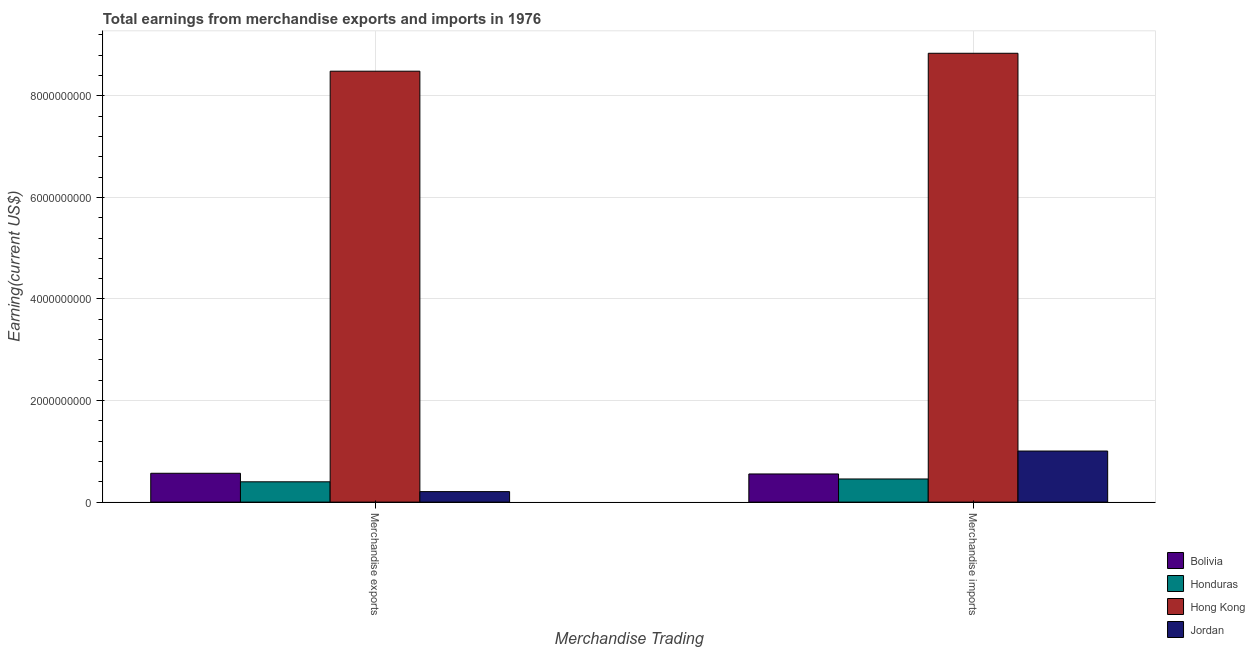How many different coloured bars are there?
Your response must be concise. 4. How many groups of bars are there?
Make the answer very short. 2. Are the number of bars per tick equal to the number of legend labels?
Offer a very short reply. Yes. Are the number of bars on each tick of the X-axis equal?
Keep it short and to the point. Yes. How many bars are there on the 1st tick from the left?
Your answer should be compact. 4. What is the label of the 1st group of bars from the left?
Ensure brevity in your answer.  Merchandise exports. What is the earnings from merchandise imports in Honduras?
Give a very brief answer. 4.56e+08. Across all countries, what is the maximum earnings from merchandise imports?
Give a very brief answer. 8.84e+09. Across all countries, what is the minimum earnings from merchandise imports?
Offer a very short reply. 4.56e+08. In which country was the earnings from merchandise exports maximum?
Offer a terse response. Hong Kong. In which country was the earnings from merchandise imports minimum?
Provide a succinct answer. Honduras. What is the total earnings from merchandise imports in the graph?
Your response must be concise. 1.09e+1. What is the difference between the earnings from merchandise imports in Jordan and that in Honduras?
Provide a short and direct response. 5.50e+08. What is the difference between the earnings from merchandise exports in Jordan and the earnings from merchandise imports in Honduras?
Offer a terse response. -2.49e+08. What is the average earnings from merchandise imports per country?
Keep it short and to the point. 2.71e+09. What is the difference between the earnings from merchandise imports and earnings from merchandise exports in Jordan?
Make the answer very short. 7.99e+08. What is the ratio of the earnings from merchandise exports in Hong Kong to that in Bolivia?
Provide a succinct answer. 14.93. In how many countries, is the earnings from merchandise imports greater than the average earnings from merchandise imports taken over all countries?
Your answer should be compact. 1. What does the 3rd bar from the left in Merchandise exports represents?
Make the answer very short. Hong Kong. What does the 1st bar from the right in Merchandise exports represents?
Your answer should be very brief. Jordan. Are the values on the major ticks of Y-axis written in scientific E-notation?
Keep it short and to the point. No. Does the graph contain grids?
Your answer should be compact. Yes. Where does the legend appear in the graph?
Your answer should be compact. Bottom right. How are the legend labels stacked?
Ensure brevity in your answer.  Vertical. What is the title of the graph?
Provide a short and direct response. Total earnings from merchandise exports and imports in 1976. Does "South Africa" appear as one of the legend labels in the graph?
Offer a very short reply. No. What is the label or title of the X-axis?
Make the answer very short. Merchandise Trading. What is the label or title of the Y-axis?
Provide a short and direct response. Earning(current US$). What is the Earning(current US$) in Bolivia in Merchandise exports?
Provide a short and direct response. 5.68e+08. What is the Earning(current US$) of Honduras in Merchandise exports?
Offer a very short reply. 4.00e+08. What is the Earning(current US$) of Hong Kong in Merchandise exports?
Offer a terse response. 8.48e+09. What is the Earning(current US$) in Jordan in Merchandise exports?
Ensure brevity in your answer.  2.07e+08. What is the Earning(current US$) of Bolivia in Merchandise imports?
Ensure brevity in your answer.  5.55e+08. What is the Earning(current US$) in Honduras in Merchandise imports?
Provide a succinct answer. 4.56e+08. What is the Earning(current US$) of Hong Kong in Merchandise imports?
Make the answer very short. 8.84e+09. What is the Earning(current US$) of Jordan in Merchandise imports?
Offer a very short reply. 1.01e+09. Across all Merchandise Trading, what is the maximum Earning(current US$) of Bolivia?
Ensure brevity in your answer.  5.68e+08. Across all Merchandise Trading, what is the maximum Earning(current US$) of Honduras?
Offer a very short reply. 4.56e+08. Across all Merchandise Trading, what is the maximum Earning(current US$) of Hong Kong?
Your response must be concise. 8.84e+09. Across all Merchandise Trading, what is the maximum Earning(current US$) of Jordan?
Offer a terse response. 1.01e+09. Across all Merchandise Trading, what is the minimum Earning(current US$) in Bolivia?
Offer a terse response. 5.55e+08. Across all Merchandise Trading, what is the minimum Earning(current US$) in Honduras?
Give a very brief answer. 4.00e+08. Across all Merchandise Trading, what is the minimum Earning(current US$) in Hong Kong?
Offer a terse response. 8.48e+09. Across all Merchandise Trading, what is the minimum Earning(current US$) in Jordan?
Your response must be concise. 2.07e+08. What is the total Earning(current US$) of Bolivia in the graph?
Your response must be concise. 1.12e+09. What is the total Earning(current US$) of Honduras in the graph?
Ensure brevity in your answer.  8.56e+08. What is the total Earning(current US$) of Hong Kong in the graph?
Your answer should be very brief. 1.73e+1. What is the total Earning(current US$) of Jordan in the graph?
Your answer should be compact. 1.21e+09. What is the difference between the Earning(current US$) in Bolivia in Merchandise exports and that in Merchandise imports?
Your response must be concise. 1.36e+07. What is the difference between the Earning(current US$) in Honduras in Merchandise exports and that in Merchandise imports?
Your answer should be compact. -5.58e+07. What is the difference between the Earning(current US$) in Hong Kong in Merchandise exports and that in Merchandise imports?
Give a very brief answer. -3.53e+08. What is the difference between the Earning(current US$) in Jordan in Merchandise exports and that in Merchandise imports?
Offer a terse response. -7.99e+08. What is the difference between the Earning(current US$) of Bolivia in Merchandise exports and the Earning(current US$) of Honduras in Merchandise imports?
Give a very brief answer. 1.12e+08. What is the difference between the Earning(current US$) in Bolivia in Merchandise exports and the Earning(current US$) in Hong Kong in Merchandise imports?
Ensure brevity in your answer.  -8.27e+09. What is the difference between the Earning(current US$) in Bolivia in Merchandise exports and the Earning(current US$) in Jordan in Merchandise imports?
Make the answer very short. -4.38e+08. What is the difference between the Earning(current US$) in Honduras in Merchandise exports and the Earning(current US$) in Hong Kong in Merchandise imports?
Your response must be concise. -8.44e+09. What is the difference between the Earning(current US$) in Honduras in Merchandise exports and the Earning(current US$) in Jordan in Merchandise imports?
Give a very brief answer. -6.06e+08. What is the difference between the Earning(current US$) of Hong Kong in Merchandise exports and the Earning(current US$) of Jordan in Merchandise imports?
Keep it short and to the point. 7.48e+09. What is the average Earning(current US$) of Bolivia per Merchandise Trading?
Provide a short and direct response. 5.61e+08. What is the average Earning(current US$) of Honduras per Merchandise Trading?
Offer a terse response. 4.28e+08. What is the average Earning(current US$) of Hong Kong per Merchandise Trading?
Your answer should be compact. 8.66e+09. What is the average Earning(current US$) of Jordan per Merchandise Trading?
Keep it short and to the point. 6.06e+08. What is the difference between the Earning(current US$) of Bolivia and Earning(current US$) of Honduras in Merchandise exports?
Your answer should be compact. 1.68e+08. What is the difference between the Earning(current US$) of Bolivia and Earning(current US$) of Hong Kong in Merchandise exports?
Your answer should be compact. -7.92e+09. What is the difference between the Earning(current US$) in Bolivia and Earning(current US$) in Jordan in Merchandise exports?
Your answer should be compact. 3.61e+08. What is the difference between the Earning(current US$) of Honduras and Earning(current US$) of Hong Kong in Merchandise exports?
Your response must be concise. -8.08e+09. What is the difference between the Earning(current US$) of Honduras and Earning(current US$) of Jordan in Merchandise exports?
Your answer should be very brief. 1.93e+08. What is the difference between the Earning(current US$) of Hong Kong and Earning(current US$) of Jordan in Merchandise exports?
Offer a terse response. 8.28e+09. What is the difference between the Earning(current US$) in Bolivia and Earning(current US$) in Honduras in Merchandise imports?
Your answer should be very brief. 9.87e+07. What is the difference between the Earning(current US$) of Bolivia and Earning(current US$) of Hong Kong in Merchandise imports?
Give a very brief answer. -8.28e+09. What is the difference between the Earning(current US$) of Bolivia and Earning(current US$) of Jordan in Merchandise imports?
Provide a succinct answer. -4.51e+08. What is the difference between the Earning(current US$) in Honduras and Earning(current US$) in Hong Kong in Merchandise imports?
Offer a terse response. -8.38e+09. What is the difference between the Earning(current US$) of Honduras and Earning(current US$) of Jordan in Merchandise imports?
Offer a very short reply. -5.50e+08. What is the difference between the Earning(current US$) of Hong Kong and Earning(current US$) of Jordan in Merchandise imports?
Offer a very short reply. 7.83e+09. What is the ratio of the Earning(current US$) of Bolivia in Merchandise exports to that in Merchandise imports?
Keep it short and to the point. 1.02. What is the ratio of the Earning(current US$) of Honduras in Merchandise exports to that in Merchandise imports?
Provide a succinct answer. 0.88. What is the ratio of the Earning(current US$) in Jordan in Merchandise exports to that in Merchandise imports?
Your answer should be compact. 0.21. What is the difference between the highest and the second highest Earning(current US$) of Bolivia?
Make the answer very short. 1.36e+07. What is the difference between the highest and the second highest Earning(current US$) in Honduras?
Your answer should be compact. 5.58e+07. What is the difference between the highest and the second highest Earning(current US$) in Hong Kong?
Offer a terse response. 3.53e+08. What is the difference between the highest and the second highest Earning(current US$) in Jordan?
Provide a succinct answer. 7.99e+08. What is the difference between the highest and the lowest Earning(current US$) of Bolivia?
Your response must be concise. 1.36e+07. What is the difference between the highest and the lowest Earning(current US$) of Honduras?
Make the answer very short. 5.58e+07. What is the difference between the highest and the lowest Earning(current US$) of Hong Kong?
Offer a terse response. 3.53e+08. What is the difference between the highest and the lowest Earning(current US$) in Jordan?
Your response must be concise. 7.99e+08. 